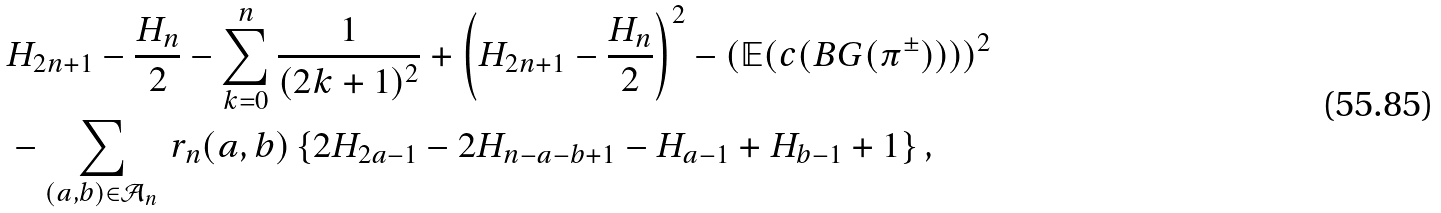<formula> <loc_0><loc_0><loc_500><loc_500>& H _ { 2 n + 1 } - \frac { H _ { n } } { 2 } - \sum _ { k = 0 } ^ { n } \frac { 1 } { ( 2 k + 1 ) ^ { 2 } } + \left ( H _ { 2 n + 1 } - \frac { H _ { n } } { 2 } \right ) ^ { 2 } - ( \mathbb { E } ( c ( B G ( \pi ^ { \pm } ) ) ) ) ^ { 2 } \\ & - \sum _ { ( a , b ) \in \mathcal { A } _ { n } } \, r _ { n } ( a , b ) \left \{ 2 H _ { 2 a - 1 } - 2 H _ { n - a - b + 1 } - H _ { a - 1 } + H _ { b - 1 } + 1 \right \} ,</formula> 